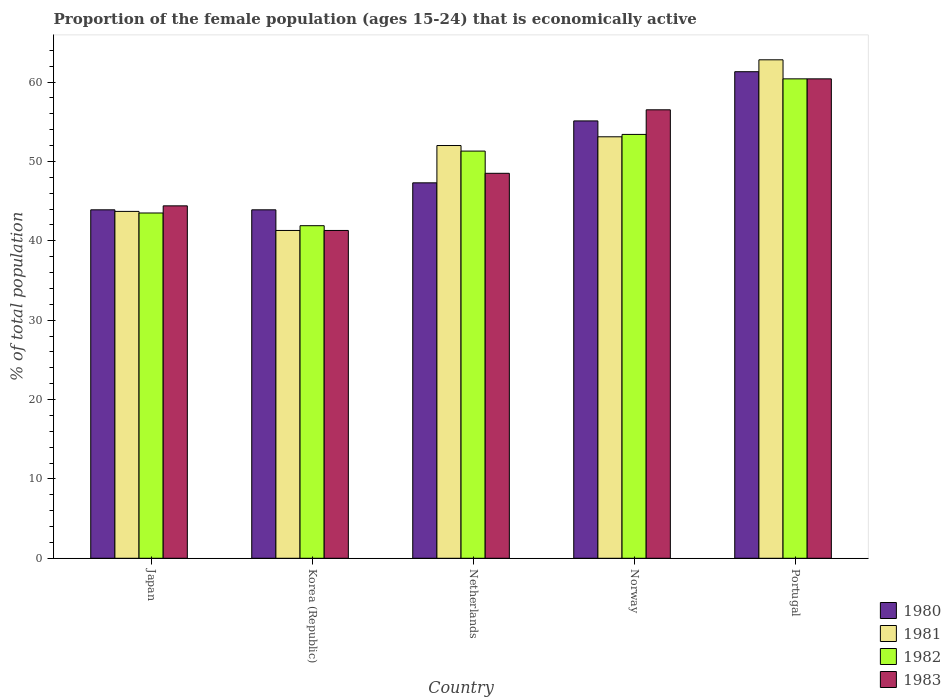How many groups of bars are there?
Provide a short and direct response. 5. Are the number of bars per tick equal to the number of legend labels?
Your answer should be very brief. Yes. Are the number of bars on each tick of the X-axis equal?
Your answer should be very brief. Yes. How many bars are there on the 3rd tick from the right?
Make the answer very short. 4. What is the label of the 3rd group of bars from the left?
Keep it short and to the point. Netherlands. What is the proportion of the female population that is economically active in 1981 in Japan?
Your answer should be very brief. 43.7. Across all countries, what is the maximum proportion of the female population that is economically active in 1983?
Ensure brevity in your answer.  60.4. Across all countries, what is the minimum proportion of the female population that is economically active in 1980?
Offer a terse response. 43.9. In which country was the proportion of the female population that is economically active in 1983 maximum?
Give a very brief answer. Portugal. What is the total proportion of the female population that is economically active in 1982 in the graph?
Your answer should be very brief. 250.5. What is the difference between the proportion of the female population that is economically active in 1983 in Korea (Republic) and that in Netherlands?
Your answer should be very brief. -7.2. What is the difference between the proportion of the female population that is economically active in 1983 in Norway and the proportion of the female population that is economically active in 1982 in Portugal?
Make the answer very short. -3.9. What is the average proportion of the female population that is economically active in 1983 per country?
Offer a very short reply. 50.22. In how many countries, is the proportion of the female population that is economically active in 1981 greater than 52 %?
Keep it short and to the point. 2. What is the ratio of the proportion of the female population that is economically active in 1983 in Netherlands to that in Norway?
Your answer should be very brief. 0.86. What is the difference between the highest and the lowest proportion of the female population that is economically active in 1981?
Your response must be concise. 21.5. Is it the case that in every country, the sum of the proportion of the female population that is economically active in 1981 and proportion of the female population that is economically active in 1980 is greater than the sum of proportion of the female population that is economically active in 1983 and proportion of the female population that is economically active in 1982?
Your answer should be very brief. No. What does the 1st bar from the right in Portugal represents?
Provide a succinct answer. 1983. How many bars are there?
Your answer should be very brief. 20. Are all the bars in the graph horizontal?
Provide a short and direct response. No. What is the difference between two consecutive major ticks on the Y-axis?
Make the answer very short. 10. Are the values on the major ticks of Y-axis written in scientific E-notation?
Your response must be concise. No. Does the graph contain any zero values?
Offer a terse response. No. Does the graph contain grids?
Your response must be concise. No. What is the title of the graph?
Ensure brevity in your answer.  Proportion of the female population (ages 15-24) that is economically active. What is the label or title of the Y-axis?
Keep it short and to the point. % of total population. What is the % of total population of 1980 in Japan?
Provide a succinct answer. 43.9. What is the % of total population of 1981 in Japan?
Give a very brief answer. 43.7. What is the % of total population in 1982 in Japan?
Give a very brief answer. 43.5. What is the % of total population in 1983 in Japan?
Your response must be concise. 44.4. What is the % of total population in 1980 in Korea (Republic)?
Make the answer very short. 43.9. What is the % of total population in 1981 in Korea (Republic)?
Keep it short and to the point. 41.3. What is the % of total population in 1982 in Korea (Republic)?
Provide a short and direct response. 41.9. What is the % of total population of 1983 in Korea (Republic)?
Your response must be concise. 41.3. What is the % of total population of 1980 in Netherlands?
Your answer should be compact. 47.3. What is the % of total population in 1982 in Netherlands?
Offer a terse response. 51.3. What is the % of total population in 1983 in Netherlands?
Offer a terse response. 48.5. What is the % of total population in 1980 in Norway?
Provide a succinct answer. 55.1. What is the % of total population in 1981 in Norway?
Your answer should be compact. 53.1. What is the % of total population in 1982 in Norway?
Keep it short and to the point. 53.4. What is the % of total population of 1983 in Norway?
Give a very brief answer. 56.5. What is the % of total population of 1980 in Portugal?
Make the answer very short. 61.3. What is the % of total population of 1981 in Portugal?
Provide a succinct answer. 62.8. What is the % of total population of 1982 in Portugal?
Make the answer very short. 60.4. What is the % of total population of 1983 in Portugal?
Give a very brief answer. 60.4. Across all countries, what is the maximum % of total population of 1980?
Make the answer very short. 61.3. Across all countries, what is the maximum % of total population of 1981?
Give a very brief answer. 62.8. Across all countries, what is the maximum % of total population in 1982?
Ensure brevity in your answer.  60.4. Across all countries, what is the maximum % of total population of 1983?
Provide a short and direct response. 60.4. Across all countries, what is the minimum % of total population in 1980?
Provide a succinct answer. 43.9. Across all countries, what is the minimum % of total population of 1981?
Your response must be concise. 41.3. Across all countries, what is the minimum % of total population in 1982?
Make the answer very short. 41.9. Across all countries, what is the minimum % of total population in 1983?
Your response must be concise. 41.3. What is the total % of total population in 1980 in the graph?
Your response must be concise. 251.5. What is the total % of total population in 1981 in the graph?
Make the answer very short. 252.9. What is the total % of total population of 1982 in the graph?
Give a very brief answer. 250.5. What is the total % of total population in 1983 in the graph?
Provide a succinct answer. 251.1. What is the difference between the % of total population of 1980 in Japan and that in Korea (Republic)?
Keep it short and to the point. 0. What is the difference between the % of total population of 1981 in Japan and that in Korea (Republic)?
Keep it short and to the point. 2.4. What is the difference between the % of total population of 1982 in Japan and that in Korea (Republic)?
Keep it short and to the point. 1.6. What is the difference between the % of total population of 1980 in Japan and that in Netherlands?
Give a very brief answer. -3.4. What is the difference between the % of total population in 1980 in Japan and that in Norway?
Make the answer very short. -11.2. What is the difference between the % of total population in 1981 in Japan and that in Norway?
Your answer should be compact. -9.4. What is the difference between the % of total population in 1980 in Japan and that in Portugal?
Make the answer very short. -17.4. What is the difference between the % of total population of 1981 in Japan and that in Portugal?
Provide a short and direct response. -19.1. What is the difference between the % of total population in 1982 in Japan and that in Portugal?
Give a very brief answer. -16.9. What is the difference between the % of total population of 1983 in Japan and that in Portugal?
Give a very brief answer. -16. What is the difference between the % of total population of 1982 in Korea (Republic) and that in Norway?
Your response must be concise. -11.5. What is the difference between the % of total population in 1983 in Korea (Republic) and that in Norway?
Your answer should be compact. -15.2. What is the difference between the % of total population in 1980 in Korea (Republic) and that in Portugal?
Your response must be concise. -17.4. What is the difference between the % of total population of 1981 in Korea (Republic) and that in Portugal?
Make the answer very short. -21.5. What is the difference between the % of total population in 1982 in Korea (Republic) and that in Portugal?
Your answer should be compact. -18.5. What is the difference between the % of total population in 1983 in Korea (Republic) and that in Portugal?
Ensure brevity in your answer.  -19.1. What is the difference between the % of total population of 1980 in Netherlands and that in Norway?
Offer a very short reply. -7.8. What is the difference between the % of total population of 1983 in Netherlands and that in Portugal?
Offer a terse response. -11.9. What is the difference between the % of total population in 1980 in Norway and that in Portugal?
Your answer should be compact. -6.2. What is the difference between the % of total population in 1983 in Norway and that in Portugal?
Your answer should be very brief. -3.9. What is the difference between the % of total population of 1981 in Japan and the % of total population of 1983 in Korea (Republic)?
Provide a short and direct response. 2.4. What is the difference between the % of total population of 1980 in Japan and the % of total population of 1981 in Netherlands?
Make the answer very short. -8.1. What is the difference between the % of total population of 1981 in Japan and the % of total population of 1982 in Netherlands?
Make the answer very short. -7.6. What is the difference between the % of total population in 1981 in Japan and the % of total population in 1983 in Netherlands?
Make the answer very short. -4.8. What is the difference between the % of total population in 1982 in Japan and the % of total population in 1983 in Netherlands?
Your response must be concise. -5. What is the difference between the % of total population of 1980 in Japan and the % of total population of 1981 in Norway?
Give a very brief answer. -9.2. What is the difference between the % of total population of 1980 in Japan and the % of total population of 1982 in Norway?
Your answer should be very brief. -9.5. What is the difference between the % of total population of 1981 in Japan and the % of total population of 1982 in Norway?
Provide a succinct answer. -9.7. What is the difference between the % of total population in 1981 in Japan and the % of total population in 1983 in Norway?
Offer a terse response. -12.8. What is the difference between the % of total population in 1982 in Japan and the % of total population in 1983 in Norway?
Ensure brevity in your answer.  -13. What is the difference between the % of total population in 1980 in Japan and the % of total population in 1981 in Portugal?
Provide a succinct answer. -18.9. What is the difference between the % of total population of 1980 in Japan and the % of total population of 1982 in Portugal?
Make the answer very short. -16.5. What is the difference between the % of total population in 1980 in Japan and the % of total population in 1983 in Portugal?
Offer a terse response. -16.5. What is the difference between the % of total population of 1981 in Japan and the % of total population of 1982 in Portugal?
Your answer should be compact. -16.7. What is the difference between the % of total population of 1981 in Japan and the % of total population of 1983 in Portugal?
Offer a very short reply. -16.7. What is the difference between the % of total population in 1982 in Japan and the % of total population in 1983 in Portugal?
Provide a short and direct response. -16.9. What is the difference between the % of total population in 1980 in Korea (Republic) and the % of total population in 1981 in Netherlands?
Offer a terse response. -8.1. What is the difference between the % of total population in 1981 in Korea (Republic) and the % of total population in 1982 in Netherlands?
Your response must be concise. -10. What is the difference between the % of total population of 1980 in Korea (Republic) and the % of total population of 1983 in Norway?
Ensure brevity in your answer.  -12.6. What is the difference between the % of total population in 1981 in Korea (Republic) and the % of total population in 1983 in Norway?
Your response must be concise. -15.2. What is the difference between the % of total population of 1982 in Korea (Republic) and the % of total population of 1983 in Norway?
Your answer should be very brief. -14.6. What is the difference between the % of total population in 1980 in Korea (Republic) and the % of total population in 1981 in Portugal?
Your answer should be compact. -18.9. What is the difference between the % of total population in 1980 in Korea (Republic) and the % of total population in 1982 in Portugal?
Keep it short and to the point. -16.5. What is the difference between the % of total population of 1980 in Korea (Republic) and the % of total population of 1983 in Portugal?
Ensure brevity in your answer.  -16.5. What is the difference between the % of total population of 1981 in Korea (Republic) and the % of total population of 1982 in Portugal?
Make the answer very short. -19.1. What is the difference between the % of total population of 1981 in Korea (Republic) and the % of total population of 1983 in Portugal?
Offer a very short reply. -19.1. What is the difference between the % of total population of 1982 in Korea (Republic) and the % of total population of 1983 in Portugal?
Provide a short and direct response. -18.5. What is the difference between the % of total population in 1980 in Netherlands and the % of total population in 1983 in Norway?
Your response must be concise. -9.2. What is the difference between the % of total population in 1981 in Netherlands and the % of total population in 1982 in Norway?
Offer a terse response. -1.4. What is the difference between the % of total population of 1982 in Netherlands and the % of total population of 1983 in Norway?
Ensure brevity in your answer.  -5.2. What is the difference between the % of total population of 1980 in Netherlands and the % of total population of 1981 in Portugal?
Provide a succinct answer. -15.5. What is the difference between the % of total population of 1980 in Netherlands and the % of total population of 1982 in Portugal?
Provide a succinct answer. -13.1. What is the difference between the % of total population of 1982 in Netherlands and the % of total population of 1983 in Portugal?
Your response must be concise. -9.1. What is the difference between the % of total population in 1980 in Norway and the % of total population in 1981 in Portugal?
Your answer should be compact. -7.7. What is the difference between the % of total population of 1980 in Norway and the % of total population of 1982 in Portugal?
Provide a short and direct response. -5.3. What is the difference between the % of total population of 1980 in Norway and the % of total population of 1983 in Portugal?
Offer a terse response. -5.3. What is the average % of total population in 1980 per country?
Provide a short and direct response. 50.3. What is the average % of total population of 1981 per country?
Keep it short and to the point. 50.58. What is the average % of total population of 1982 per country?
Your response must be concise. 50.1. What is the average % of total population of 1983 per country?
Provide a short and direct response. 50.22. What is the difference between the % of total population of 1980 and % of total population of 1981 in Japan?
Offer a terse response. 0.2. What is the difference between the % of total population of 1981 and % of total population of 1982 in Japan?
Make the answer very short. 0.2. What is the difference between the % of total population in 1982 and % of total population in 1983 in Japan?
Offer a very short reply. -0.9. What is the difference between the % of total population in 1980 and % of total population in 1981 in Korea (Republic)?
Provide a succinct answer. 2.6. What is the difference between the % of total population in 1980 and % of total population in 1982 in Korea (Republic)?
Offer a terse response. 2. What is the difference between the % of total population in 1980 and % of total population in 1983 in Korea (Republic)?
Give a very brief answer. 2.6. What is the difference between the % of total population in 1981 and % of total population in 1983 in Korea (Republic)?
Your response must be concise. 0. What is the difference between the % of total population of 1980 and % of total population of 1982 in Netherlands?
Ensure brevity in your answer.  -4. What is the difference between the % of total population in 1980 and % of total population in 1983 in Netherlands?
Make the answer very short. -1.2. What is the difference between the % of total population of 1981 and % of total population of 1982 in Netherlands?
Your answer should be very brief. 0.7. What is the difference between the % of total population of 1981 and % of total population of 1983 in Netherlands?
Give a very brief answer. 3.5. What is the difference between the % of total population of 1982 and % of total population of 1983 in Netherlands?
Give a very brief answer. 2.8. What is the difference between the % of total population of 1982 and % of total population of 1983 in Norway?
Ensure brevity in your answer.  -3.1. What is the difference between the % of total population of 1980 and % of total population of 1983 in Portugal?
Give a very brief answer. 0.9. What is the difference between the % of total population of 1981 and % of total population of 1983 in Portugal?
Ensure brevity in your answer.  2.4. What is the ratio of the % of total population in 1980 in Japan to that in Korea (Republic)?
Offer a terse response. 1. What is the ratio of the % of total population in 1981 in Japan to that in Korea (Republic)?
Your answer should be compact. 1.06. What is the ratio of the % of total population of 1982 in Japan to that in Korea (Republic)?
Provide a short and direct response. 1.04. What is the ratio of the % of total population of 1983 in Japan to that in Korea (Republic)?
Offer a very short reply. 1.08. What is the ratio of the % of total population in 1980 in Japan to that in Netherlands?
Your response must be concise. 0.93. What is the ratio of the % of total population of 1981 in Japan to that in Netherlands?
Make the answer very short. 0.84. What is the ratio of the % of total population of 1982 in Japan to that in Netherlands?
Give a very brief answer. 0.85. What is the ratio of the % of total population of 1983 in Japan to that in Netherlands?
Provide a short and direct response. 0.92. What is the ratio of the % of total population in 1980 in Japan to that in Norway?
Make the answer very short. 0.8. What is the ratio of the % of total population of 1981 in Japan to that in Norway?
Ensure brevity in your answer.  0.82. What is the ratio of the % of total population in 1982 in Japan to that in Norway?
Your answer should be very brief. 0.81. What is the ratio of the % of total population of 1983 in Japan to that in Norway?
Give a very brief answer. 0.79. What is the ratio of the % of total population in 1980 in Japan to that in Portugal?
Your response must be concise. 0.72. What is the ratio of the % of total population in 1981 in Japan to that in Portugal?
Ensure brevity in your answer.  0.7. What is the ratio of the % of total population in 1982 in Japan to that in Portugal?
Provide a short and direct response. 0.72. What is the ratio of the % of total population of 1983 in Japan to that in Portugal?
Your answer should be compact. 0.74. What is the ratio of the % of total population of 1980 in Korea (Republic) to that in Netherlands?
Keep it short and to the point. 0.93. What is the ratio of the % of total population of 1981 in Korea (Republic) to that in Netherlands?
Provide a short and direct response. 0.79. What is the ratio of the % of total population of 1982 in Korea (Republic) to that in Netherlands?
Provide a short and direct response. 0.82. What is the ratio of the % of total population of 1983 in Korea (Republic) to that in Netherlands?
Offer a terse response. 0.85. What is the ratio of the % of total population of 1980 in Korea (Republic) to that in Norway?
Make the answer very short. 0.8. What is the ratio of the % of total population of 1981 in Korea (Republic) to that in Norway?
Make the answer very short. 0.78. What is the ratio of the % of total population in 1982 in Korea (Republic) to that in Norway?
Keep it short and to the point. 0.78. What is the ratio of the % of total population of 1983 in Korea (Republic) to that in Norway?
Provide a succinct answer. 0.73. What is the ratio of the % of total population in 1980 in Korea (Republic) to that in Portugal?
Ensure brevity in your answer.  0.72. What is the ratio of the % of total population in 1981 in Korea (Republic) to that in Portugal?
Offer a very short reply. 0.66. What is the ratio of the % of total population in 1982 in Korea (Republic) to that in Portugal?
Give a very brief answer. 0.69. What is the ratio of the % of total population in 1983 in Korea (Republic) to that in Portugal?
Provide a succinct answer. 0.68. What is the ratio of the % of total population in 1980 in Netherlands to that in Norway?
Offer a very short reply. 0.86. What is the ratio of the % of total population of 1981 in Netherlands to that in Norway?
Your answer should be very brief. 0.98. What is the ratio of the % of total population in 1982 in Netherlands to that in Norway?
Ensure brevity in your answer.  0.96. What is the ratio of the % of total population in 1983 in Netherlands to that in Norway?
Your answer should be very brief. 0.86. What is the ratio of the % of total population of 1980 in Netherlands to that in Portugal?
Provide a succinct answer. 0.77. What is the ratio of the % of total population of 1981 in Netherlands to that in Portugal?
Give a very brief answer. 0.83. What is the ratio of the % of total population in 1982 in Netherlands to that in Portugal?
Keep it short and to the point. 0.85. What is the ratio of the % of total population in 1983 in Netherlands to that in Portugal?
Your answer should be compact. 0.8. What is the ratio of the % of total population in 1980 in Norway to that in Portugal?
Provide a succinct answer. 0.9. What is the ratio of the % of total population of 1981 in Norway to that in Portugal?
Offer a very short reply. 0.85. What is the ratio of the % of total population in 1982 in Norway to that in Portugal?
Your answer should be very brief. 0.88. What is the ratio of the % of total population of 1983 in Norway to that in Portugal?
Provide a short and direct response. 0.94. What is the difference between the highest and the second highest % of total population of 1980?
Ensure brevity in your answer.  6.2. What is the difference between the highest and the second highest % of total population of 1981?
Ensure brevity in your answer.  9.7. What is the difference between the highest and the second highest % of total population of 1983?
Your response must be concise. 3.9. What is the difference between the highest and the lowest % of total population of 1980?
Offer a very short reply. 17.4. What is the difference between the highest and the lowest % of total population in 1981?
Keep it short and to the point. 21.5. What is the difference between the highest and the lowest % of total population of 1982?
Provide a short and direct response. 18.5. 